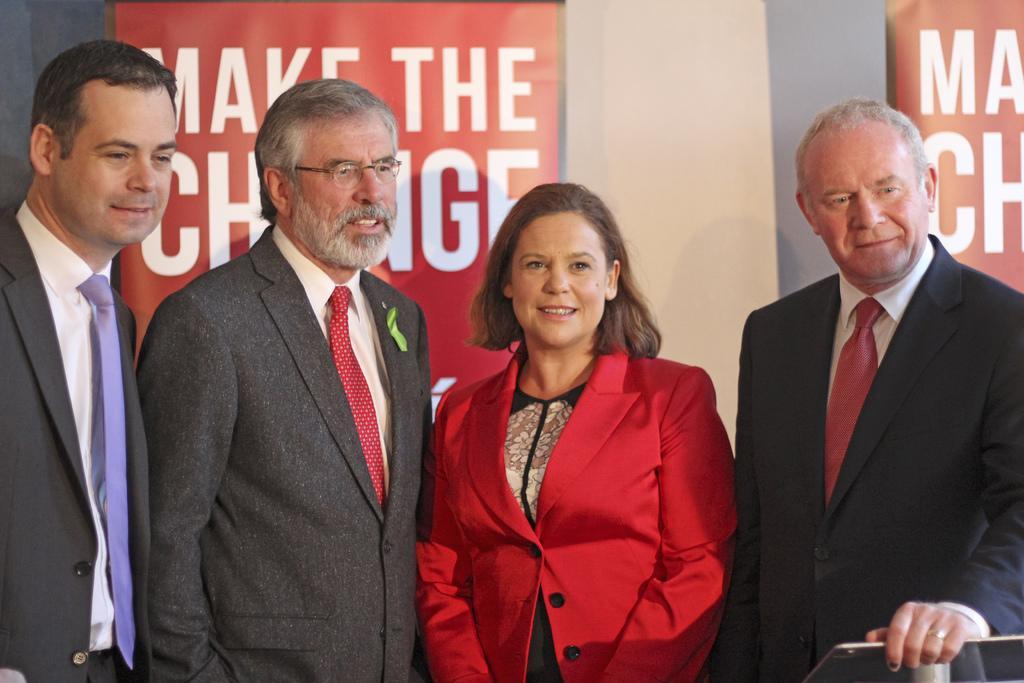In one or two sentences, can you explain what this image depicts? In this image I can see three men wearing white shirts and black blazers are standing and a woman wearing black and red dress is standing between them. In the background I can see the white colored wall and two banners which are red and white in color. 